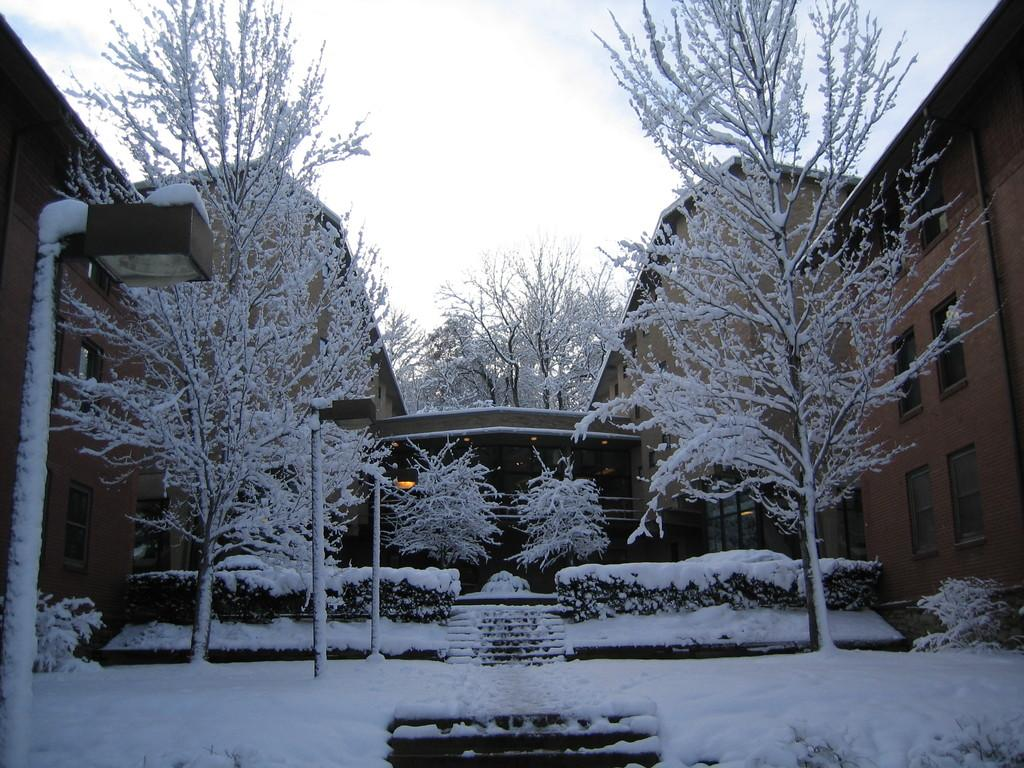What can be seen in the background of the image? The sky is visible in the background of the image. What type of structures are present on both sides of the image? There are buildings with windows on the right and left sides of the image. What is the condition of the trees in the image? The trees in the image have snow on them. Who is the creator of the snow in the image? The image does not provide information about the creator of the snow; it simply shows snow-covered trees. Is there a maid visible in the image? There is no mention of a maid or any person in the image; it only features buildings, trees, and the sky. 